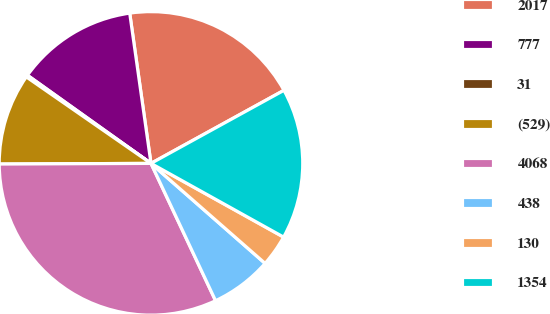Convert chart to OTSL. <chart><loc_0><loc_0><loc_500><loc_500><pie_chart><fcel>2017<fcel>777<fcel>31<fcel>(529)<fcel>4068<fcel>438<fcel>130<fcel>1354<nl><fcel>19.24%<fcel>12.9%<fcel>0.21%<fcel>9.72%<fcel>31.93%<fcel>6.55%<fcel>3.38%<fcel>16.07%<nl></chart> 